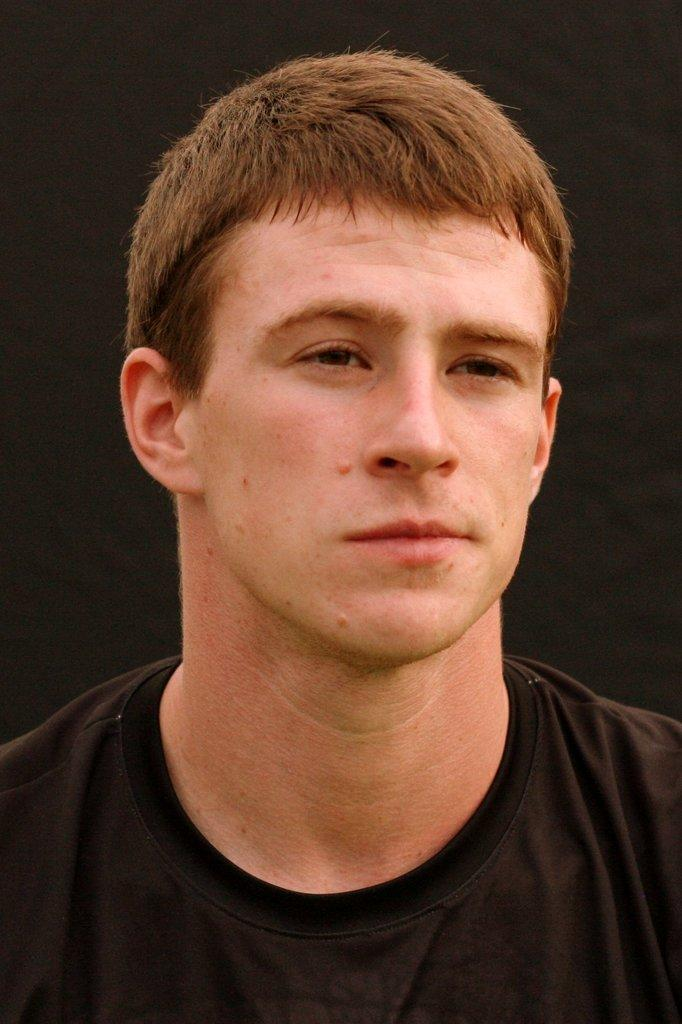Who is present in the image? There is a man in the picture. What is the man wearing? The man is wearing a black t-shirt. What can be seen in the background of the image? The background of the image is black. What type of flower is sitting on the chair in the image? There is no flower or chair present in the image; it only features a man wearing a black t-shirt against a black background. 